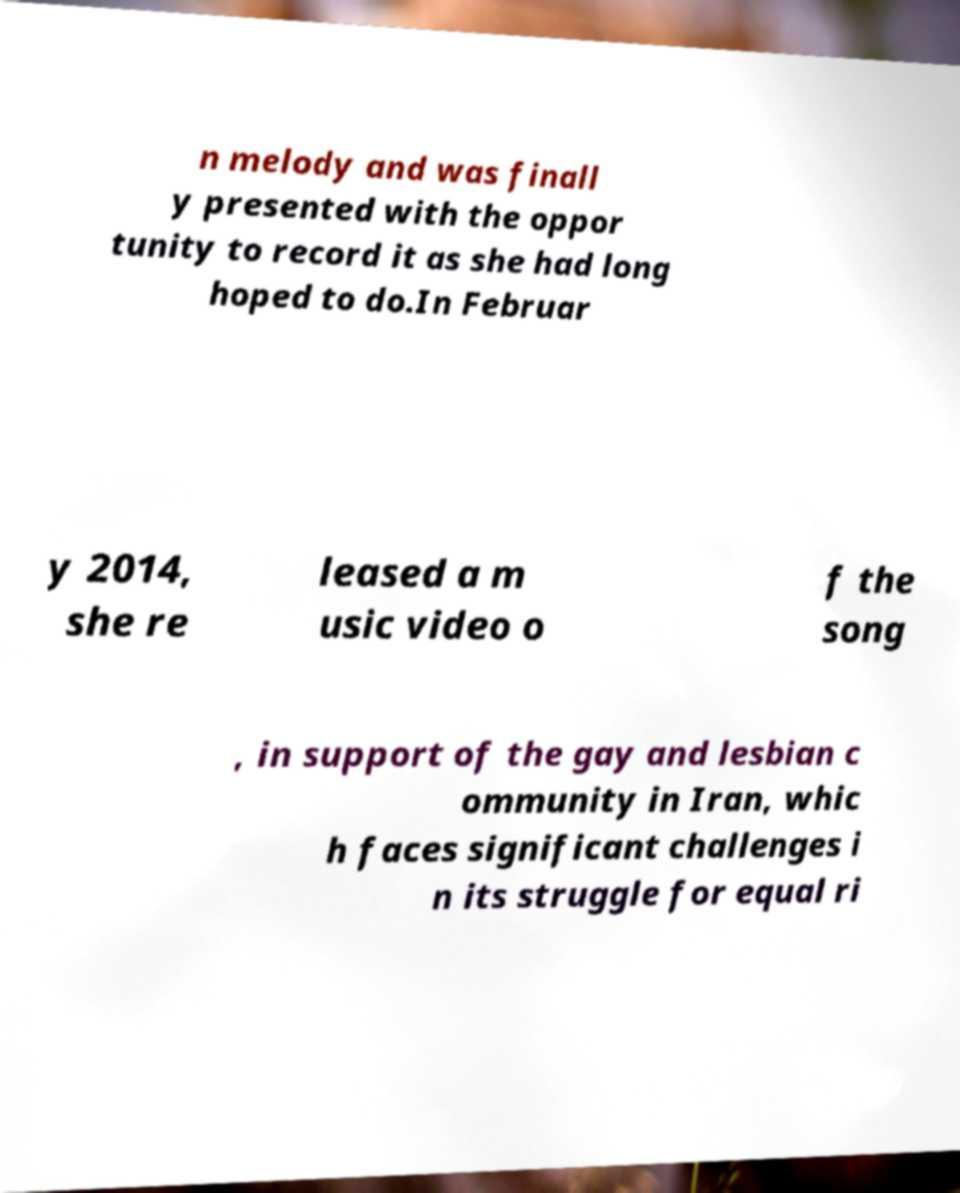I need the written content from this picture converted into text. Can you do that? n melody and was finall y presented with the oppor tunity to record it as she had long hoped to do.In Februar y 2014, she re leased a m usic video o f the song , in support of the gay and lesbian c ommunity in Iran, whic h faces significant challenges i n its struggle for equal ri 